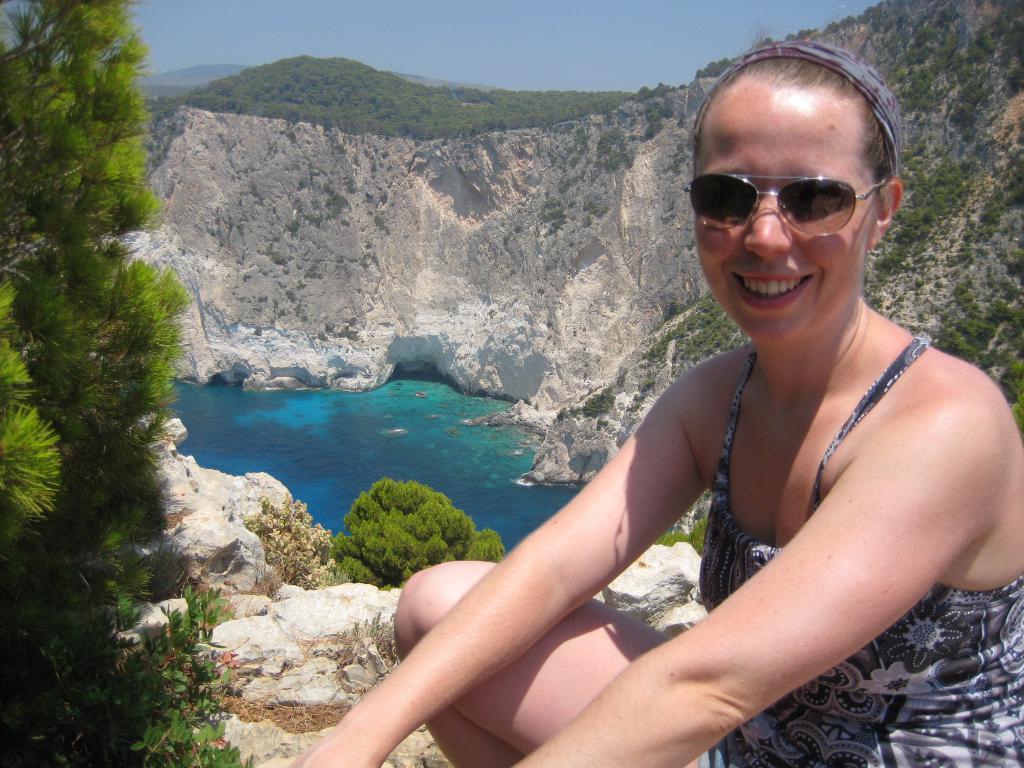How would you summarize this image in a sentence or two? In the foreground I can see a woman sitting, smiling and giving pose for the picture. On the left side I can see some plants. In the background there is a river and around this I can see many rocks and plants. At the top of the image I can see in the sky. 